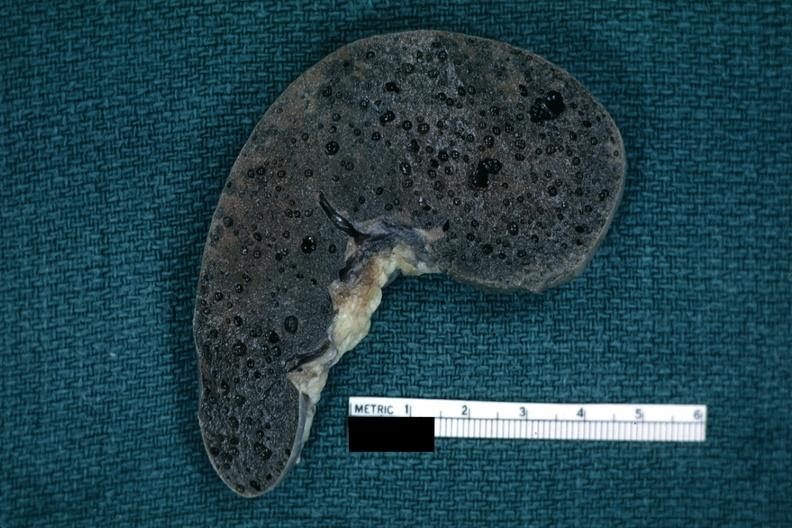s hematologic present?
Answer the question using a single word or phrase. Yes 